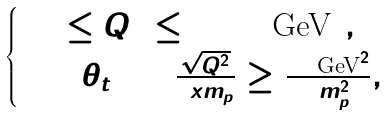Convert formula to latex. <formula><loc_0><loc_0><loc_500><loc_500>\begin{cases} 1 0 \leq Q ^ { 2 } \leq 1 0 0 0 \, \text {GeV} ^ { 2 } , \\ \cos ( \theta _ { t } ) = \frac { \sqrt { Q ^ { 2 } } } { 2 x m _ { p } } \geq \frac { 4 9 \, \text {GeV} ^ { 2 } } { 2 m _ { p } ^ { 2 } } , \end{cases}</formula> 